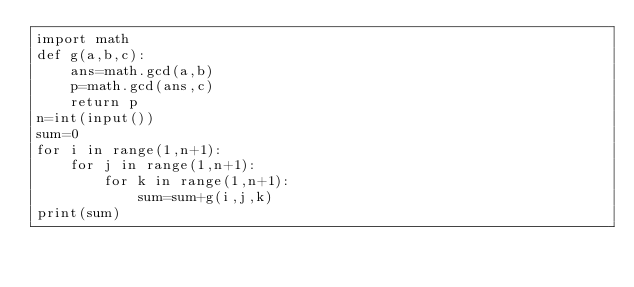Convert code to text. <code><loc_0><loc_0><loc_500><loc_500><_Python_>import math
def g(a,b,c):
    ans=math.gcd(a,b)
    p=math.gcd(ans,c)
    return p
n=int(input())
sum=0
for i in range(1,n+1):
    for j in range(1,n+1):
        for k in range(1,n+1):
            sum=sum+g(i,j,k)
print(sum)
</code> 